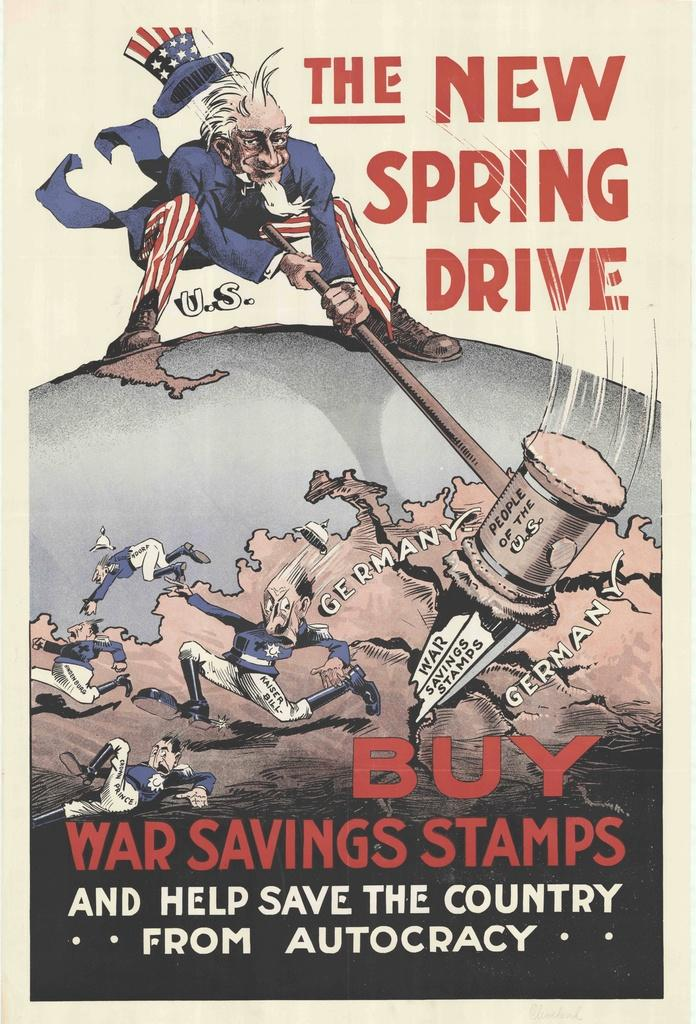<image>
Present a compact description of the photo's key features. The New Spring drive poster shows Uncle Sam hitting a hammer 